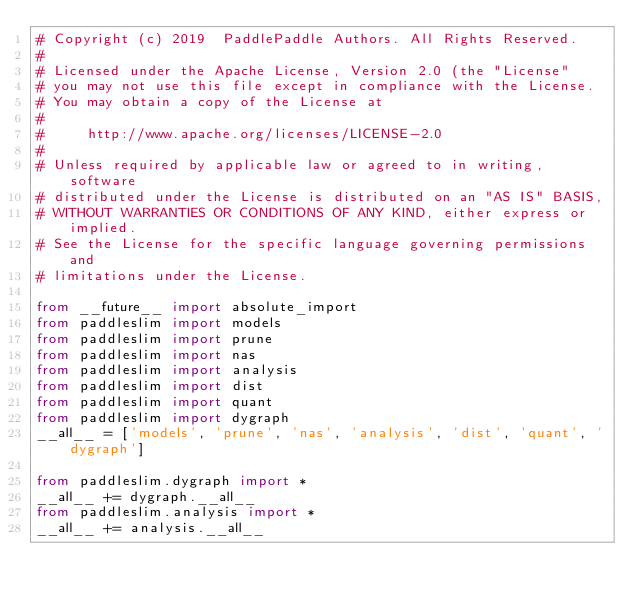Convert code to text. <code><loc_0><loc_0><loc_500><loc_500><_Python_># Copyright (c) 2019  PaddlePaddle Authors. All Rights Reserved.
#
# Licensed under the Apache License, Version 2.0 (the "License"
# you may not use this file except in compliance with the License.
# You may obtain a copy of the License at
#
#     http://www.apache.org/licenses/LICENSE-2.0
#
# Unless required by applicable law or agreed to in writing, software
# distributed under the License is distributed on an "AS IS" BASIS,
# WITHOUT WARRANTIES OR CONDITIONS OF ANY KIND, either express or implied.
# See the License for the specific language governing permissions and
# limitations under the License.

from __future__ import absolute_import
from paddleslim import models
from paddleslim import prune
from paddleslim import nas
from paddleslim import analysis
from paddleslim import dist
from paddleslim import quant
from paddleslim import dygraph
__all__ = ['models', 'prune', 'nas', 'analysis', 'dist', 'quant', 'dygraph']

from paddleslim.dygraph import *
__all__ += dygraph.__all__
from paddleslim.analysis import *
__all__ += analysis.__all__
</code> 